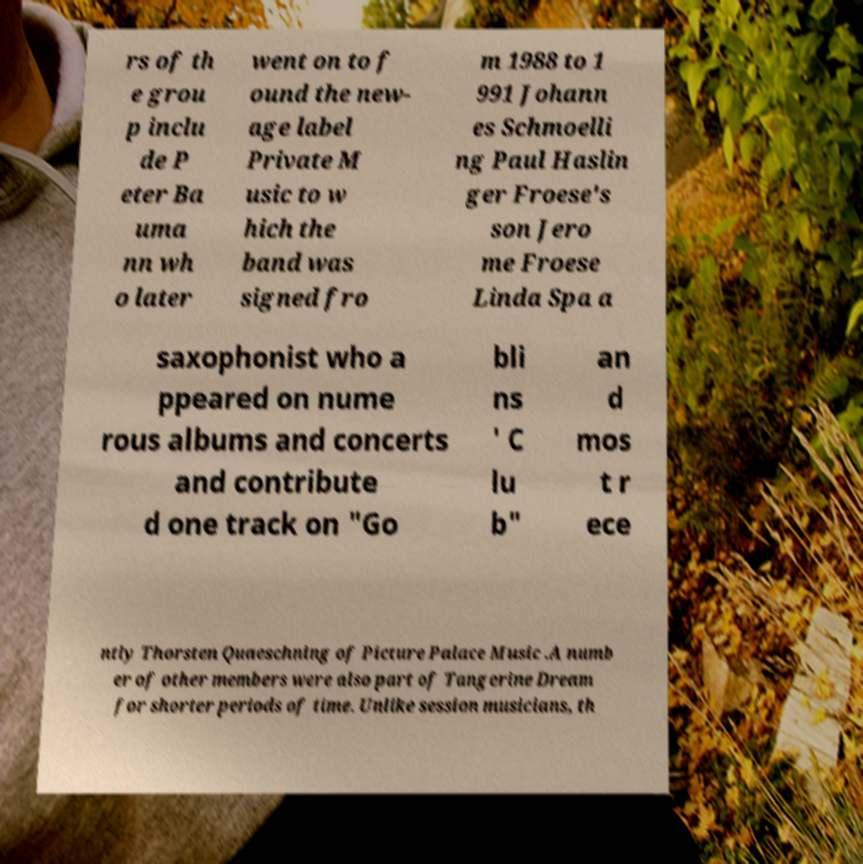Please read and relay the text visible in this image. What does it say? rs of th e grou p inclu de P eter Ba uma nn wh o later went on to f ound the new- age label Private M usic to w hich the band was signed fro m 1988 to 1 991 Johann es Schmoelli ng Paul Haslin ger Froese's son Jero me Froese Linda Spa a saxophonist who a ppeared on nume rous albums and concerts and contribute d one track on "Go bli ns ' C lu b" an d mos t r ece ntly Thorsten Quaeschning of Picture Palace Music .A numb er of other members were also part of Tangerine Dream for shorter periods of time. Unlike session musicians, th 